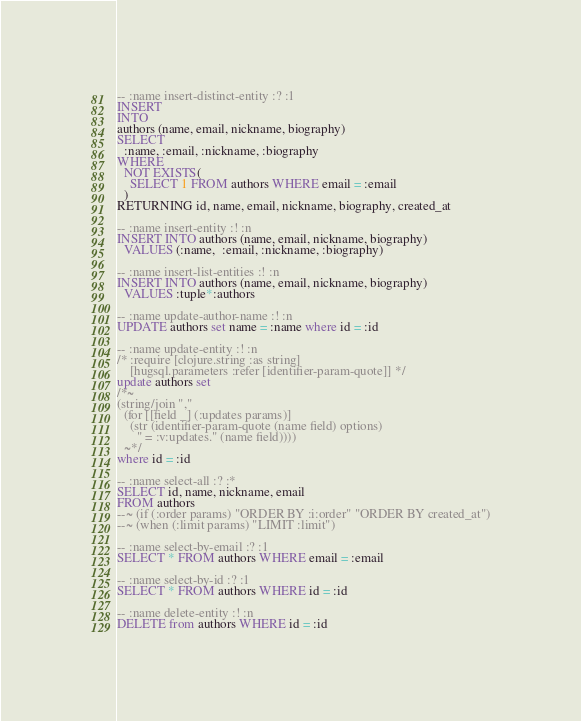Convert code to text. <code><loc_0><loc_0><loc_500><loc_500><_SQL_>-- :name insert-distinct-entity :? :1
INSERT
INTO
authors (name, email, nickname, biography)
SELECT
  :name, :email, :nickname, :biography
WHERE
  NOT EXISTS(
    SELECT 1 FROM authors WHERE email = :email
  )
RETURNING id, name, email, nickname, biography, created_at

-- :name insert-entity :! :n
INSERT INTO authors (name, email, nickname, biography)
  VALUES (:name,  :email, :nickname, :biography)

-- :name insert-list-entities :! :n
INSERT INTO authors (name, email, nickname, biography)
  VALUES :tuple*:authors

-- :name update-author-name :! :n
UPDATE authors set name = :name where id = :id

-- :name update-entity :! :n
/* :require [clojure.string :as string]
    [hugsql.parameters :refer [identifier-param-quote]] */
update authors set
/*~
(string/join ","
  (for [[field _] (:updates params)]
    (str (identifier-param-quote (name field) options)
      " = :v:updates." (name field))))
  ~*/
where id = :id

-- :name select-all :? :*
SELECT id, name, nickname, email
FROM authors
--~ (if (:order params) "ORDER BY :i:order" "ORDER BY created_at")
--~ (when (:limit params) "LIMIT :limit")

-- :name select-by-email :? :1
SELECT * FROM authors WHERE email = :email

-- :name select-by-id :? :1
SELECT * FROM authors WHERE id = :id

-- :name delete-entity :! :n
DELETE from authors WHERE id = :id
</code> 